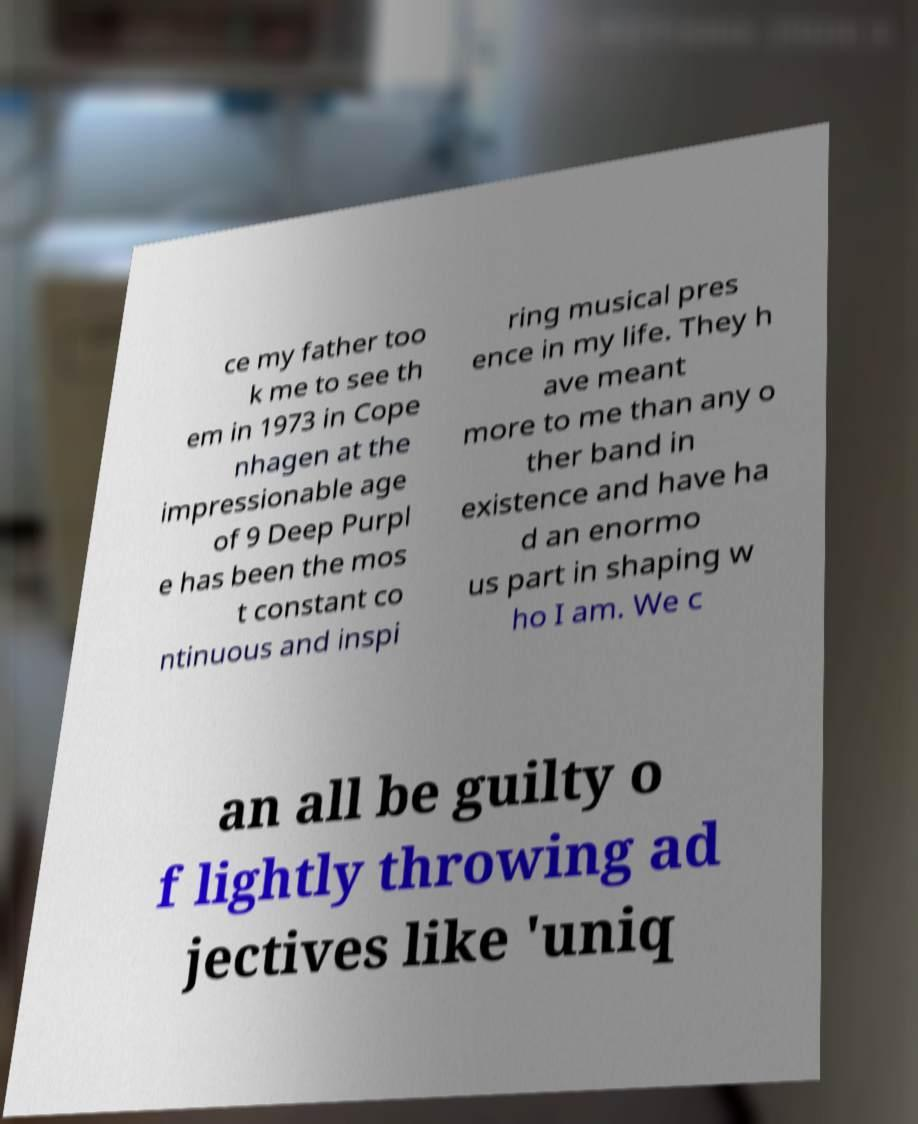Can you accurately transcribe the text from the provided image for me? ce my father too k me to see th em in 1973 in Cope nhagen at the impressionable age of 9 Deep Purpl e has been the mos t constant co ntinuous and inspi ring musical pres ence in my life. They h ave meant more to me than any o ther band in existence and have ha d an enormo us part in shaping w ho I am. We c an all be guilty o f lightly throwing ad jectives like 'uniq 